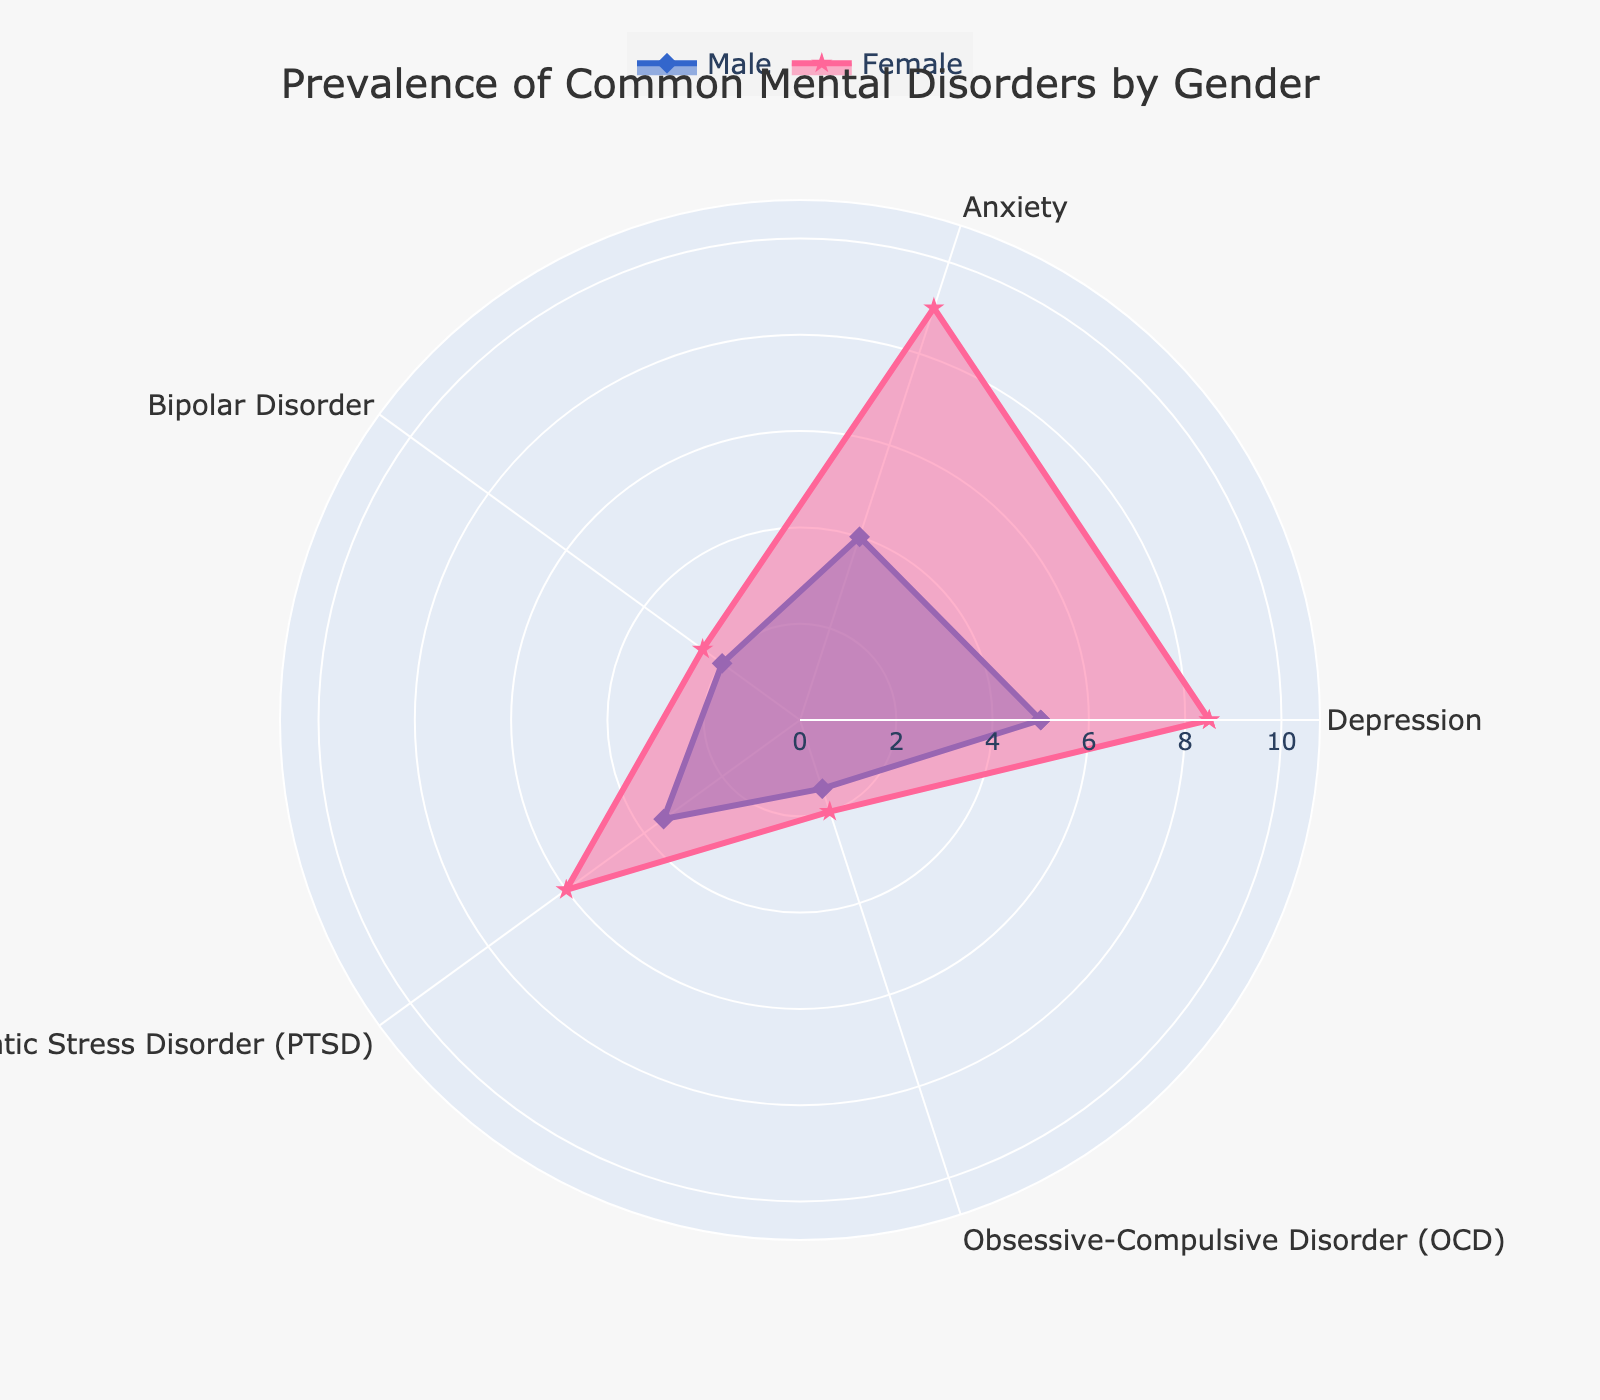What's the title of the figure? The title is typically placed prominently at the top of the figure. By reading it, you can understand the overall theme of the graph.
Answer: Prevalence of Common Mental Disorders by Gender How many mental disorders are depicted in the figure? Count the number of unique categories or axes labeled on the radar chart.
Answer: 5 Which gender shows a higher prevalence of Anxiety? Look for the data points corresponding to Anxiety and compare the values for Male and Female. The one with the greater value answers the question.
Answer: Female What is the range of the radial axis in the figure? The radial axis range can usually be found as part of the axis labels or by looking at the maximum values extended outward from the center.
Answer: 0 to 10.8 Which mental disorder has the smallest gender difference in prevalence? Calculate the difference between Male and Female values for each disorder and find the one with the smallest absolute difference. In this case, Bipolar Disorder has a male value of 2.0 and female value of 2.5, leading to a difference of 0.5, which is the smallest.
Answer: Bipolar Disorder What is the sum of the prevalence for males with Depression and OCD? Add up the values for Depression and OCD under the Male category. It is 5.0 + 1.5.
Answer: 6.5 What is the average prevalence of mental disorders for females? Add the prevalences for females for each disorder and divide by the number of disorders. (8.5 + 9.0 + 2.5 + 6.0 + 2.0) / 5 = 28 / 5
Answer: 5.6 In which mental disorder is the difference between Male and Female prevalence the greatest? Calculate the difference between Male and Female values for each disorder. Identify the maximum difference. Depression has a male value of 5.0 and female value of 8.5, leading to a difference of 3.5, which is the greatest.
Answer: Depression 